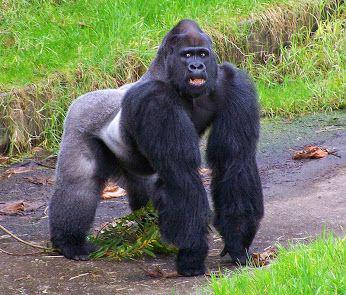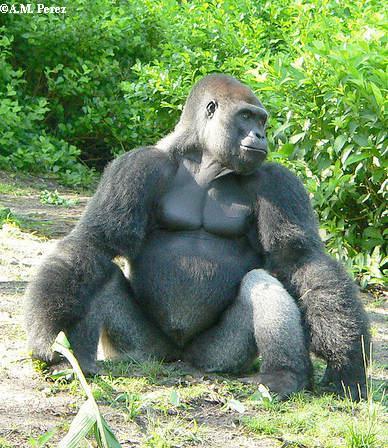The first image is the image on the left, the second image is the image on the right. Examine the images to the left and right. Is the description "The gorilla in the image on the left is touching the ground with both of it's arms." accurate? Answer yes or no. Yes. 